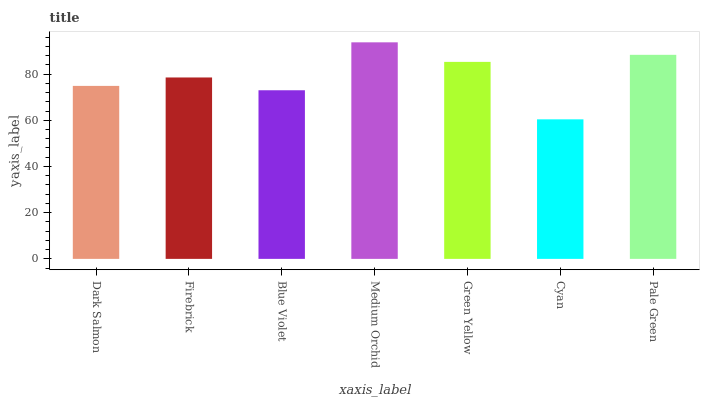Is Cyan the minimum?
Answer yes or no. Yes. Is Medium Orchid the maximum?
Answer yes or no. Yes. Is Firebrick the minimum?
Answer yes or no. No. Is Firebrick the maximum?
Answer yes or no. No. Is Firebrick greater than Dark Salmon?
Answer yes or no. Yes. Is Dark Salmon less than Firebrick?
Answer yes or no. Yes. Is Dark Salmon greater than Firebrick?
Answer yes or no. No. Is Firebrick less than Dark Salmon?
Answer yes or no. No. Is Firebrick the high median?
Answer yes or no. Yes. Is Firebrick the low median?
Answer yes or no. Yes. Is Green Yellow the high median?
Answer yes or no. No. Is Green Yellow the low median?
Answer yes or no. No. 